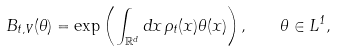Convert formula to latex. <formula><loc_0><loc_0><loc_500><loc_500>B _ { t , V } ( \theta ) = \exp \left ( \int _ { \mathbb { R } ^ { d } } d x \, \rho _ { t } ( x ) \theta ( x ) \right ) , \quad \theta \in L ^ { 1 } ,</formula> 